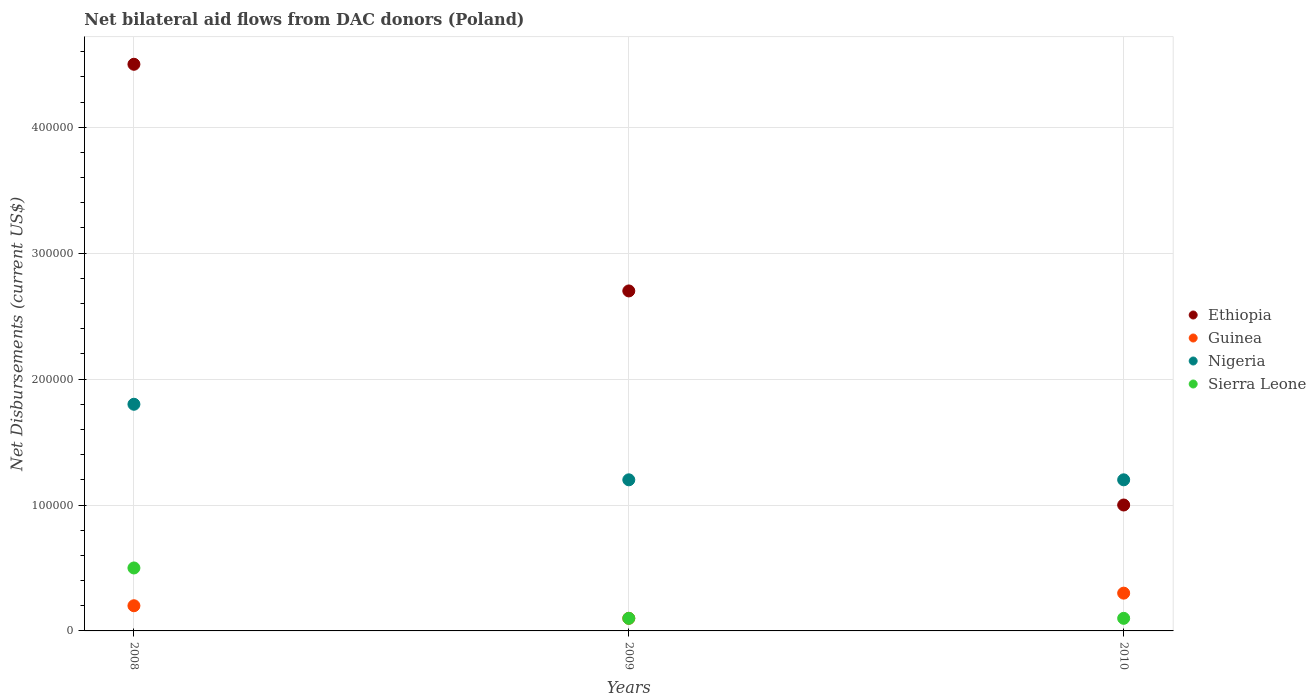What is the net bilateral aid flows in Nigeria in 2009?
Make the answer very short. 1.20e+05. Across all years, what is the maximum net bilateral aid flows in Nigeria?
Your answer should be compact. 1.80e+05. Across all years, what is the minimum net bilateral aid flows in Sierra Leone?
Keep it short and to the point. 10000. In which year was the net bilateral aid flows in Sierra Leone maximum?
Ensure brevity in your answer.  2008. What is the total net bilateral aid flows in Sierra Leone in the graph?
Give a very brief answer. 7.00e+04. What is the difference between the net bilateral aid flows in Sierra Leone in 2008 and the net bilateral aid flows in Nigeria in 2009?
Your answer should be compact. -7.00e+04. What is the average net bilateral aid flows in Sierra Leone per year?
Provide a succinct answer. 2.33e+04. In the year 2008, what is the difference between the net bilateral aid flows in Sierra Leone and net bilateral aid flows in Nigeria?
Keep it short and to the point. -1.30e+05. In how many years, is the net bilateral aid flows in Ethiopia greater than 140000 US$?
Your response must be concise. 2. Is the sum of the net bilateral aid flows in Guinea in 2009 and 2010 greater than the maximum net bilateral aid flows in Ethiopia across all years?
Provide a short and direct response. No. Does the net bilateral aid flows in Guinea monotonically increase over the years?
Your response must be concise. No. Is the net bilateral aid flows in Guinea strictly greater than the net bilateral aid flows in Nigeria over the years?
Provide a short and direct response. No. How many dotlines are there?
Give a very brief answer. 4. Does the graph contain any zero values?
Keep it short and to the point. No. Does the graph contain grids?
Make the answer very short. Yes. How many legend labels are there?
Provide a short and direct response. 4. How are the legend labels stacked?
Provide a short and direct response. Vertical. What is the title of the graph?
Offer a very short reply. Net bilateral aid flows from DAC donors (Poland). What is the label or title of the Y-axis?
Your answer should be compact. Net Disbursements (current US$). What is the Net Disbursements (current US$) in Guinea in 2008?
Your answer should be very brief. 2.00e+04. What is the Net Disbursements (current US$) in Sierra Leone in 2008?
Make the answer very short. 5.00e+04. What is the Net Disbursements (current US$) of Guinea in 2009?
Provide a succinct answer. 10000. What is the Net Disbursements (current US$) in Sierra Leone in 2009?
Provide a short and direct response. 10000. What is the Net Disbursements (current US$) of Nigeria in 2010?
Keep it short and to the point. 1.20e+05. Across all years, what is the maximum Net Disbursements (current US$) of Ethiopia?
Make the answer very short. 4.50e+05. Across all years, what is the maximum Net Disbursements (current US$) of Guinea?
Your answer should be compact. 3.00e+04. Across all years, what is the maximum Net Disbursements (current US$) in Nigeria?
Offer a very short reply. 1.80e+05. Across all years, what is the maximum Net Disbursements (current US$) of Sierra Leone?
Your answer should be very brief. 5.00e+04. Across all years, what is the minimum Net Disbursements (current US$) of Ethiopia?
Your answer should be compact. 1.00e+05. Across all years, what is the minimum Net Disbursements (current US$) of Guinea?
Give a very brief answer. 10000. Across all years, what is the minimum Net Disbursements (current US$) of Nigeria?
Keep it short and to the point. 1.20e+05. Across all years, what is the minimum Net Disbursements (current US$) in Sierra Leone?
Offer a terse response. 10000. What is the total Net Disbursements (current US$) in Ethiopia in the graph?
Offer a very short reply. 8.20e+05. What is the total Net Disbursements (current US$) of Guinea in the graph?
Offer a very short reply. 6.00e+04. What is the difference between the Net Disbursements (current US$) of Sierra Leone in 2008 and that in 2009?
Offer a very short reply. 4.00e+04. What is the difference between the Net Disbursements (current US$) of Ethiopia in 2008 and that in 2010?
Provide a succinct answer. 3.50e+05. What is the difference between the Net Disbursements (current US$) of Sierra Leone in 2008 and that in 2010?
Offer a very short reply. 4.00e+04. What is the difference between the Net Disbursements (current US$) of Ethiopia in 2009 and that in 2010?
Ensure brevity in your answer.  1.70e+05. What is the difference between the Net Disbursements (current US$) in Guinea in 2009 and that in 2010?
Offer a terse response. -2.00e+04. What is the difference between the Net Disbursements (current US$) in Sierra Leone in 2009 and that in 2010?
Ensure brevity in your answer.  0. What is the difference between the Net Disbursements (current US$) of Ethiopia in 2008 and the Net Disbursements (current US$) of Guinea in 2009?
Your answer should be compact. 4.40e+05. What is the difference between the Net Disbursements (current US$) of Ethiopia in 2008 and the Net Disbursements (current US$) of Nigeria in 2009?
Your answer should be compact. 3.30e+05. What is the difference between the Net Disbursements (current US$) of Guinea in 2008 and the Net Disbursements (current US$) of Nigeria in 2009?
Your response must be concise. -1.00e+05. What is the difference between the Net Disbursements (current US$) in Guinea in 2008 and the Net Disbursements (current US$) in Sierra Leone in 2009?
Make the answer very short. 10000. What is the difference between the Net Disbursements (current US$) of Ethiopia in 2008 and the Net Disbursements (current US$) of Guinea in 2010?
Your answer should be compact. 4.20e+05. What is the difference between the Net Disbursements (current US$) in Ethiopia in 2008 and the Net Disbursements (current US$) in Nigeria in 2010?
Make the answer very short. 3.30e+05. What is the difference between the Net Disbursements (current US$) in Guinea in 2008 and the Net Disbursements (current US$) in Nigeria in 2010?
Offer a terse response. -1.00e+05. What is the difference between the Net Disbursements (current US$) in Nigeria in 2008 and the Net Disbursements (current US$) in Sierra Leone in 2010?
Offer a very short reply. 1.70e+05. What is the difference between the Net Disbursements (current US$) in Ethiopia in 2009 and the Net Disbursements (current US$) in Guinea in 2010?
Your answer should be very brief. 2.40e+05. What is the difference between the Net Disbursements (current US$) of Ethiopia in 2009 and the Net Disbursements (current US$) of Nigeria in 2010?
Your answer should be compact. 1.50e+05. What is the difference between the Net Disbursements (current US$) of Guinea in 2009 and the Net Disbursements (current US$) of Nigeria in 2010?
Keep it short and to the point. -1.10e+05. What is the average Net Disbursements (current US$) in Ethiopia per year?
Provide a succinct answer. 2.73e+05. What is the average Net Disbursements (current US$) in Guinea per year?
Give a very brief answer. 2.00e+04. What is the average Net Disbursements (current US$) of Nigeria per year?
Keep it short and to the point. 1.40e+05. What is the average Net Disbursements (current US$) of Sierra Leone per year?
Your response must be concise. 2.33e+04. In the year 2008, what is the difference between the Net Disbursements (current US$) in Ethiopia and Net Disbursements (current US$) in Sierra Leone?
Your response must be concise. 4.00e+05. In the year 2008, what is the difference between the Net Disbursements (current US$) in Guinea and Net Disbursements (current US$) in Sierra Leone?
Your answer should be compact. -3.00e+04. In the year 2009, what is the difference between the Net Disbursements (current US$) in Ethiopia and Net Disbursements (current US$) in Nigeria?
Offer a very short reply. 1.50e+05. In the year 2009, what is the difference between the Net Disbursements (current US$) of Ethiopia and Net Disbursements (current US$) of Sierra Leone?
Provide a succinct answer. 2.60e+05. In the year 2009, what is the difference between the Net Disbursements (current US$) in Guinea and Net Disbursements (current US$) in Nigeria?
Your response must be concise. -1.10e+05. In the year 2009, what is the difference between the Net Disbursements (current US$) of Guinea and Net Disbursements (current US$) of Sierra Leone?
Provide a short and direct response. 0. In the year 2010, what is the difference between the Net Disbursements (current US$) in Ethiopia and Net Disbursements (current US$) in Guinea?
Your answer should be very brief. 7.00e+04. In the year 2010, what is the difference between the Net Disbursements (current US$) of Ethiopia and Net Disbursements (current US$) of Nigeria?
Give a very brief answer. -2.00e+04. In the year 2010, what is the difference between the Net Disbursements (current US$) of Guinea and Net Disbursements (current US$) of Nigeria?
Your answer should be compact. -9.00e+04. In the year 2010, what is the difference between the Net Disbursements (current US$) of Nigeria and Net Disbursements (current US$) of Sierra Leone?
Give a very brief answer. 1.10e+05. What is the ratio of the Net Disbursements (current US$) in Ethiopia in 2008 to that in 2009?
Your response must be concise. 1.67. What is the ratio of the Net Disbursements (current US$) of Guinea in 2008 to that in 2009?
Offer a terse response. 2. What is the ratio of the Net Disbursements (current US$) in Sierra Leone in 2008 to that in 2009?
Provide a succinct answer. 5. What is the ratio of the Net Disbursements (current US$) in Ethiopia in 2008 to that in 2010?
Your response must be concise. 4.5. What is the ratio of the Net Disbursements (current US$) in Sierra Leone in 2008 to that in 2010?
Your answer should be compact. 5. What is the ratio of the Net Disbursements (current US$) of Ethiopia in 2009 to that in 2010?
Give a very brief answer. 2.7. What is the ratio of the Net Disbursements (current US$) of Guinea in 2009 to that in 2010?
Ensure brevity in your answer.  0.33. What is the ratio of the Net Disbursements (current US$) of Sierra Leone in 2009 to that in 2010?
Offer a very short reply. 1. What is the difference between the highest and the second highest Net Disbursements (current US$) of Nigeria?
Your answer should be very brief. 6.00e+04. What is the difference between the highest and the lowest Net Disbursements (current US$) in Nigeria?
Provide a succinct answer. 6.00e+04. 